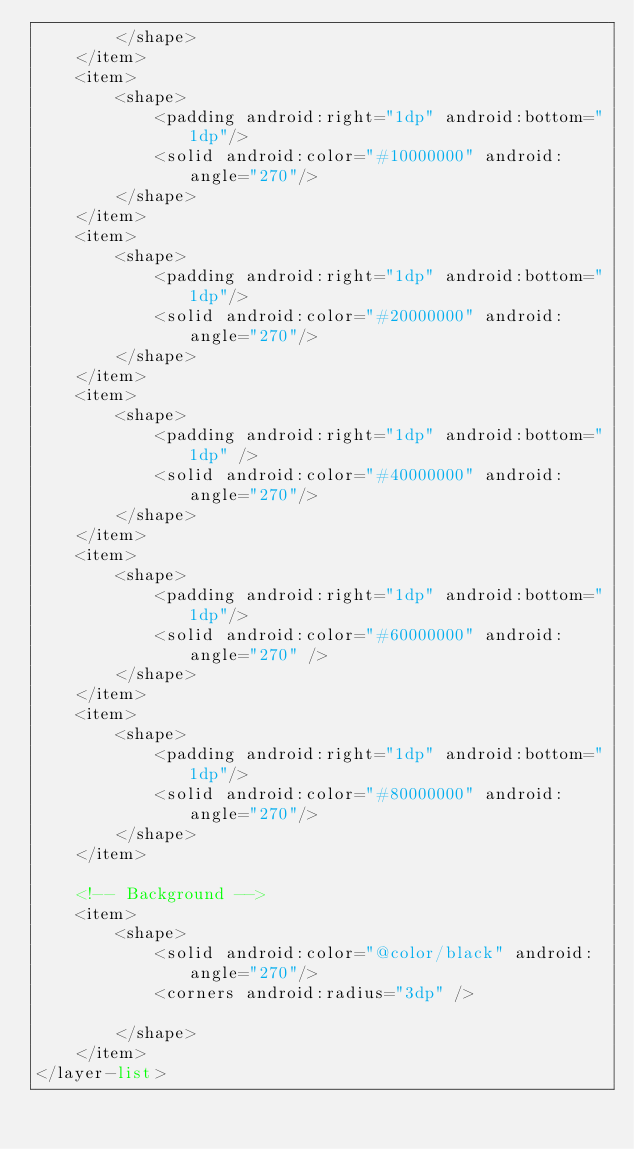Convert code to text. <code><loc_0><loc_0><loc_500><loc_500><_XML_>        </shape>
    </item>
    <item>
        <shape>
            <padding android:right="1dp" android:bottom="1dp"/>
            <solid android:color="#10000000" android:angle="270"/>
        </shape>
    </item>
    <item>
        <shape>
            <padding android:right="1dp" android:bottom="1dp"/>
            <solid android:color="#20000000" android:angle="270"/>
        </shape>
    </item>
    <item>
        <shape>
            <padding android:right="1dp" android:bottom="1dp" />
            <solid android:color="#40000000" android:angle="270"/>
        </shape>
    </item>
    <item>
        <shape>
            <padding android:right="1dp" android:bottom="1dp"/>
            <solid android:color="#60000000" android:angle="270" />
        </shape>
    </item>
    <item>
        <shape>
            <padding android:right="1dp" android:bottom="1dp"/>
            <solid android:color="#80000000" android:angle="270"/>
        </shape>
    </item>

    <!-- Background -->
    <item>
        <shape>
            <solid android:color="@color/black" android:angle="270"/>
            <corners android:radius="3dp" />

        </shape>
    </item>
</layer-list></code> 